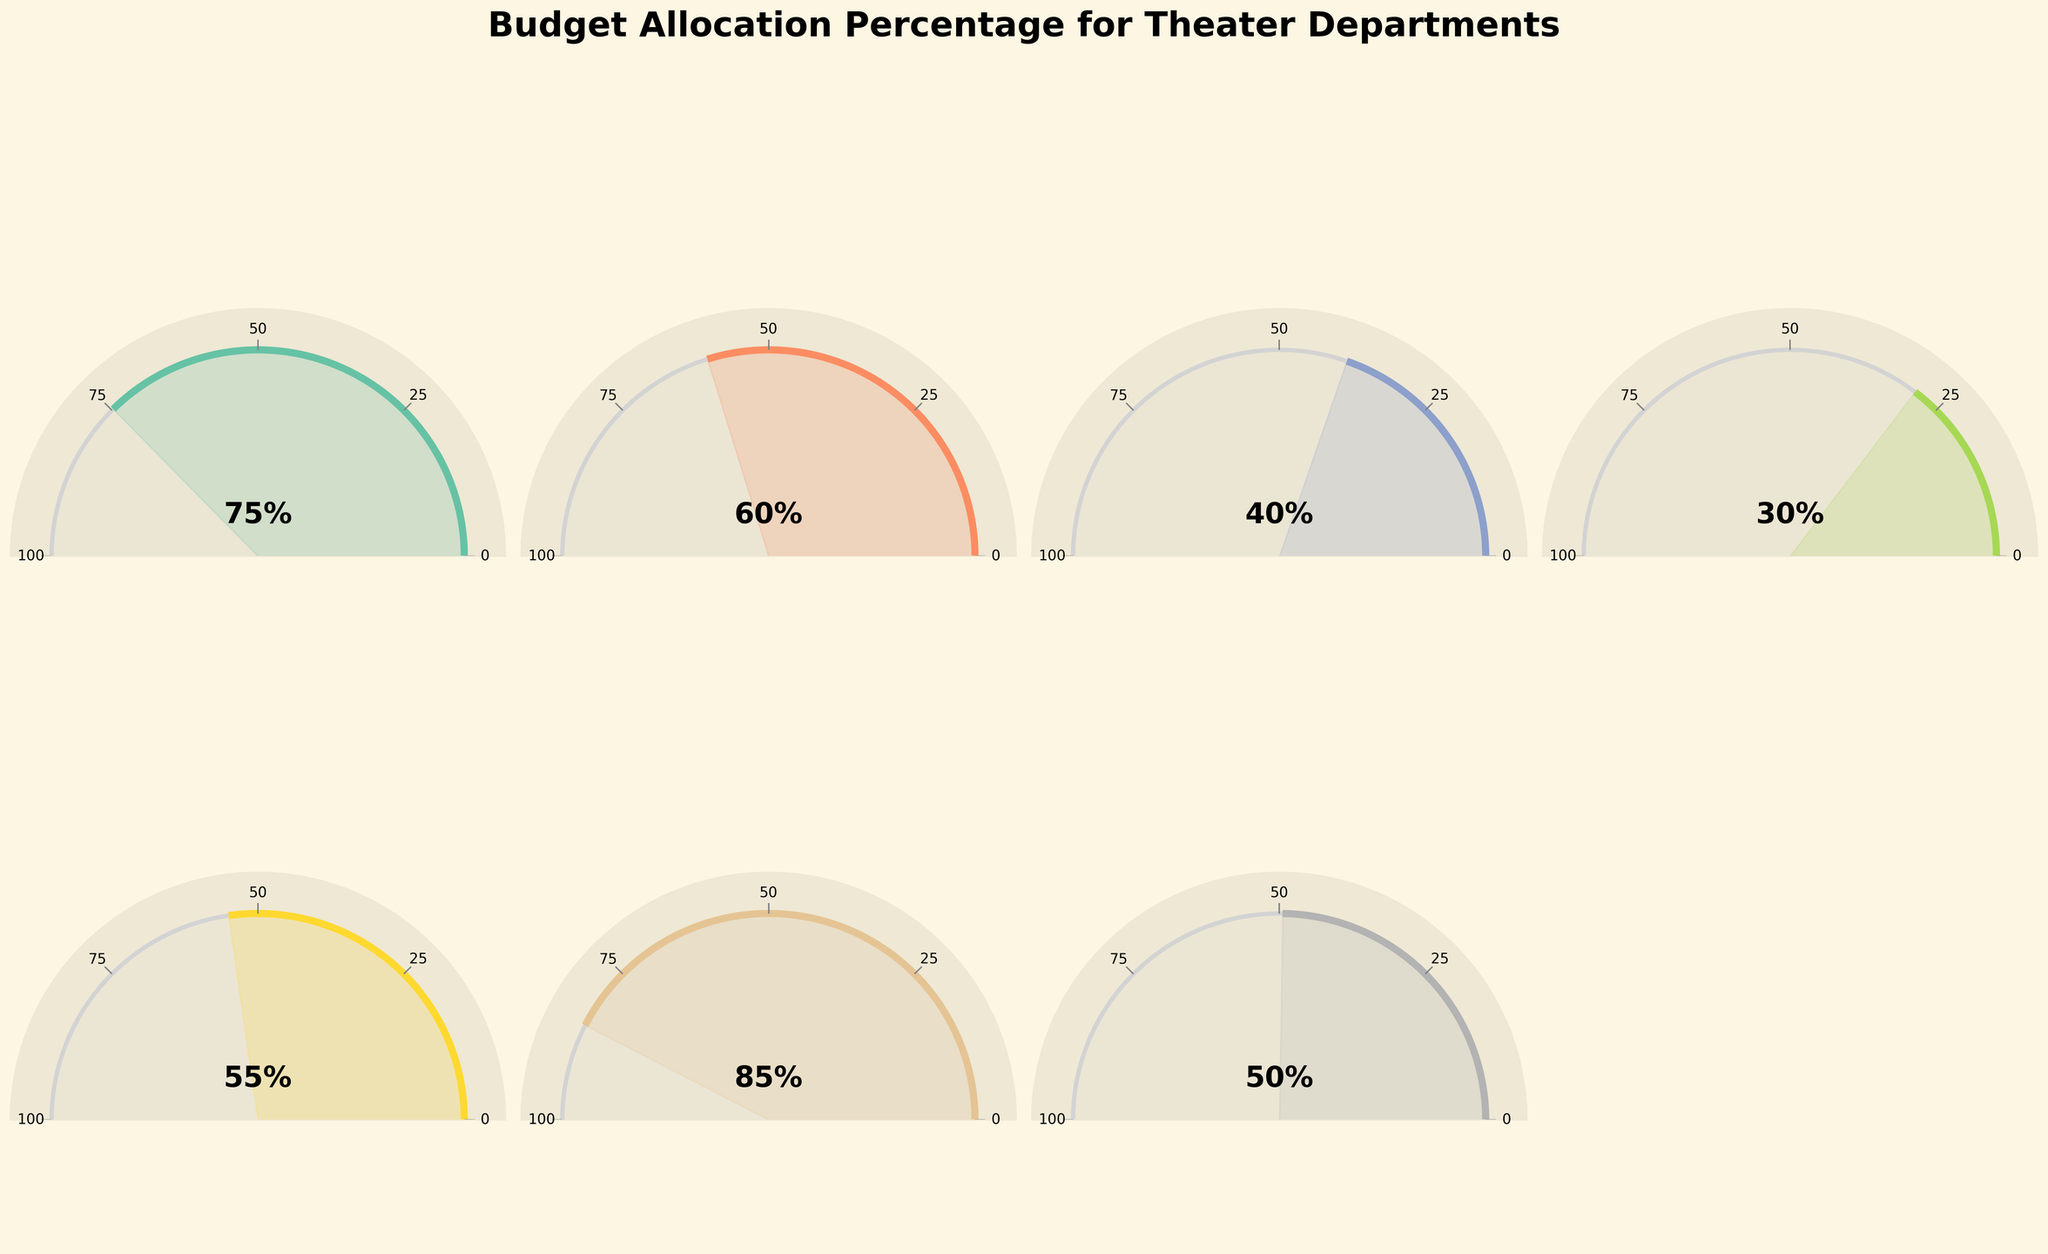What's the highest budget allocation percentage shown in the figure? The highest budget allocation percentage is indicated on the figure by checking the gauge charts and finding the maximum value. The Props Department gauge shows 85%, which is the highest.
Answer: 85% Which department has the lowest budget allocation? The department with the lowest budget allocation can be identified by looking at the values in the gauge charts. The Sound Design department has the lowest with 30%.
Answer: Sound Design What is the total of the budget allocation percentages for Set Design and Costume Department? To find the total, sum the percentages for Set Design (75%) and Costume Department (60%): 75 + 60 = 135.
Answer: 135% How many departments have a budget allocation percentage of 50% or higher? Count the departments whose gauge shows 50% or more. These departments are Set Design, Costume Department, Special Effects, Props Department, and Makeup and Hair. There are 5 departments.
Answer: 5 Which department's budget allocation is closest to 50%? Compare all departments' percentages with 50% and find the one that is closest. Makeup and Hair has exactly 50%, making it the closest.
Answer: Makeup and Hair Is the budget allocation for Lighting Design greater than that for Sound Design? Compare the percentages: Lighting Design has 40%, and Sound Design has 30%. Since 40% is greater than 30%, the answer is yes.
Answer: Yes What is the average budget allocation percentage for all the departments? Sum all the percentages and divide by the number of departments: (75+60+40+30+55+85+50) / 7 = 395 / 7 ≈ 56.4.
Answer: 56.4% Which department has the second highest budget allocation percentage? Arrange the percentages in descending order and find the second highest. Props Department has the highest (85%), and Set Design has the next highest at 75%.
Answer: Set Design What is the difference in budget allocation between the Costume Department and Special Effects? Subtract the percentage for Special Effects from the Costume Department: 60 - 55 = 5.
Answer: 5% How does the gauge marking for 50% appear on the gauge charts? In the gauge charts, 50% is marked midway between 0 and 100, often found at the midpoint of the gauge's semicircular arc.
Answer: Midway on the arc 